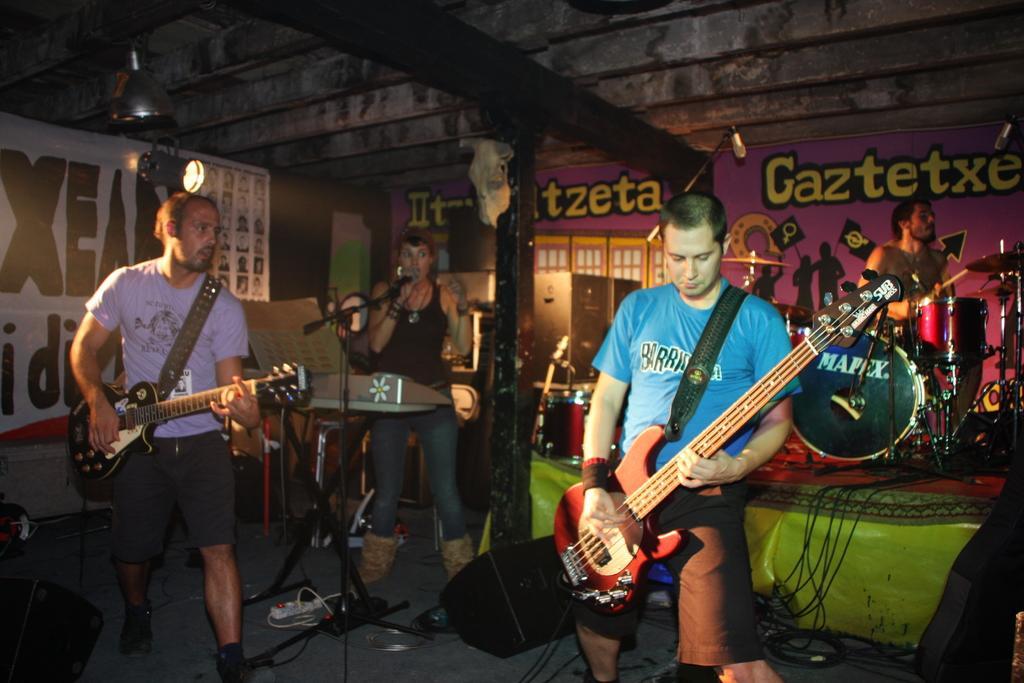Describe this image in one or two sentences. In the right and left two men are standing and playing the guitars in the middle a woman is playing musical instrument and also singing in the microphone the right a man is sitting and playing drums. 